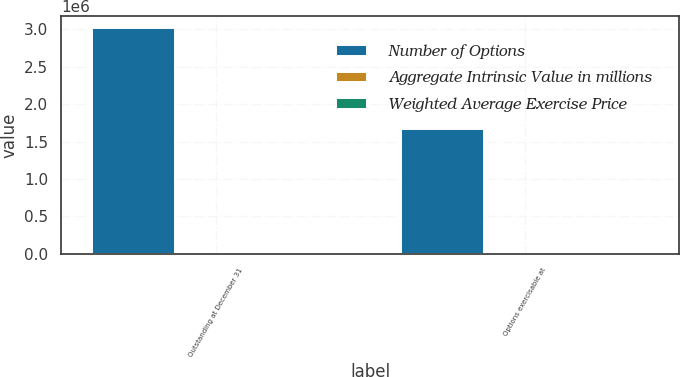<chart> <loc_0><loc_0><loc_500><loc_500><stacked_bar_chart><ecel><fcel>Outstanding at December 31<fcel>Options exercisable at<nl><fcel>Number of Options<fcel>3.02608e+06<fcel>1.66248e+06<nl><fcel>Aggregate Intrinsic Value in millions<fcel>45.05<fcel>39.94<nl><fcel>Weighted Average Exercise Price<fcel>102.3<fcel>64.7<nl></chart> 